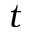<formula> <loc_0><loc_0><loc_500><loc_500>t</formula> 